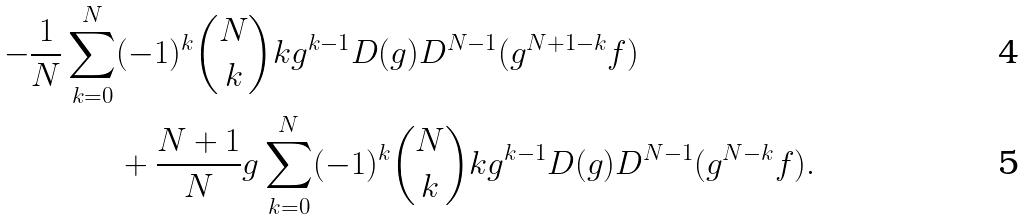<formula> <loc_0><loc_0><loc_500><loc_500>- \frac { 1 } { N } \sum _ { k = 0 } ^ { N } & ( - 1 ) ^ { k } \binom { N } { k } k g ^ { k - 1 } D ( g ) D ^ { N - 1 } ( g ^ { N + 1 - k } f ) \\ & + \frac { N + 1 } N g \sum _ { k = 0 } ^ { N } ( - 1 ) ^ { k } \binom { N } { k } k g ^ { k - 1 } D ( g ) D ^ { N - 1 } ( g ^ { N - k } f ) .</formula> 